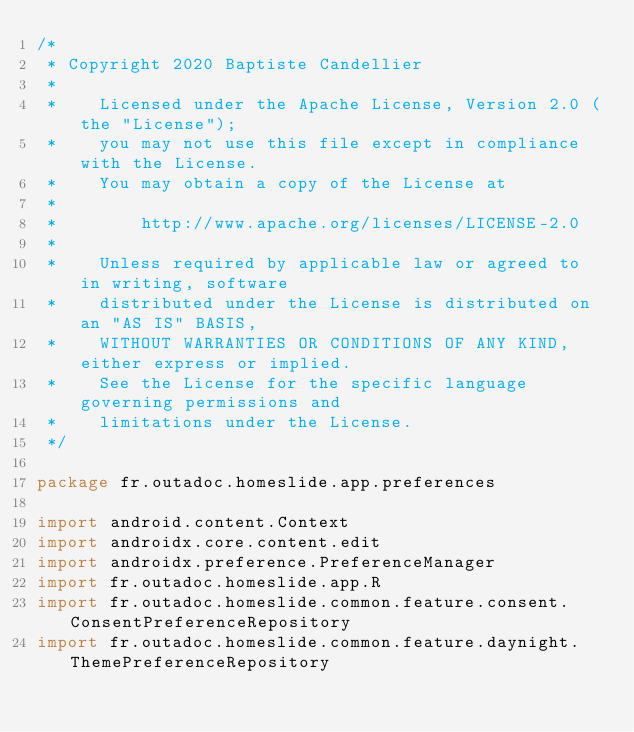Convert code to text. <code><loc_0><loc_0><loc_500><loc_500><_Kotlin_>/*
 * Copyright 2020 Baptiste Candellier
 *
 *    Licensed under the Apache License, Version 2.0 (the "License");
 *    you may not use this file except in compliance with the License.
 *    You may obtain a copy of the License at
 *
 *        http://www.apache.org/licenses/LICENSE-2.0
 *
 *    Unless required by applicable law or agreed to in writing, software
 *    distributed under the License is distributed on an "AS IS" BASIS,
 *    WITHOUT WARRANTIES OR CONDITIONS OF ANY KIND, either express or implied.
 *    See the License for the specific language governing permissions and
 *    limitations under the License.
 */

package fr.outadoc.homeslide.app.preferences

import android.content.Context
import androidx.core.content.edit
import androidx.preference.PreferenceManager
import fr.outadoc.homeslide.app.R
import fr.outadoc.homeslide.common.feature.consent.ConsentPreferenceRepository
import fr.outadoc.homeslide.common.feature.daynight.ThemePreferenceRepository</code> 